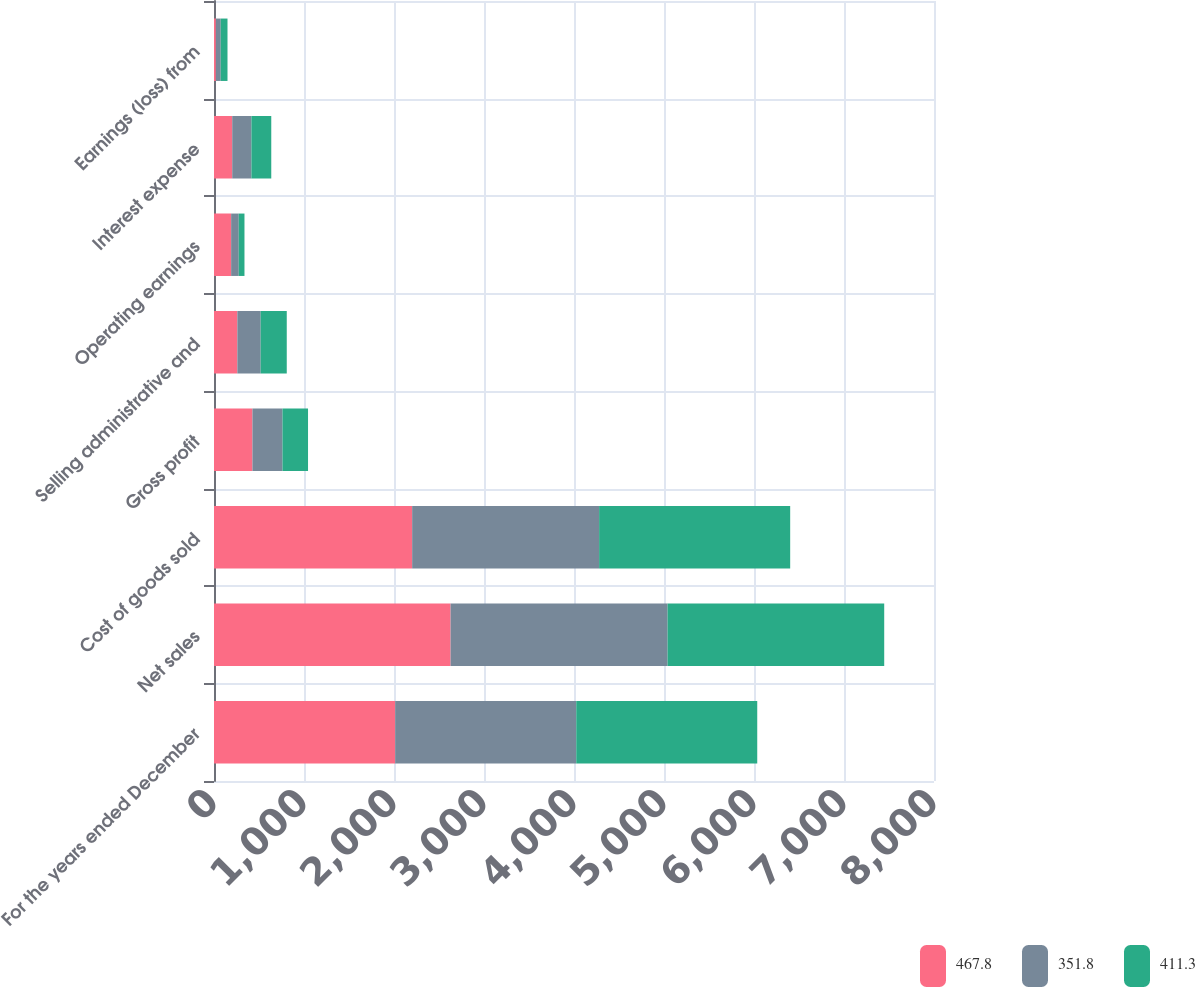Convert chart to OTSL. <chart><loc_0><loc_0><loc_500><loc_500><stacked_bar_chart><ecel><fcel>For the years ended December<fcel>Net sales<fcel>Cost of goods sold<fcel>Gross profit<fcel>Selling administrative and<fcel>Operating earnings<fcel>Interest expense<fcel>Earnings (loss) from<nl><fcel>467.8<fcel>2013<fcel>2628.7<fcel>2201.8<fcel>426.9<fcel>259.4<fcel>190.4<fcel>202.6<fcel>20.8<nl><fcel>351.8<fcel>2012<fcel>2411.2<fcel>2077.2<fcel>334<fcel>259.1<fcel>84.8<fcel>213.1<fcel>53.9<nl><fcel>411.3<fcel>2011<fcel>2406.9<fcel>2123<fcel>283.9<fcel>290<fcel>63.4<fcel>220.6<fcel>75.3<nl></chart> 